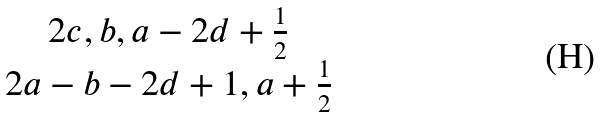<formula> <loc_0><loc_0><loc_500><loc_500>\begin{matrix} { 2 c , b , a - 2 d + \frac { 1 } { 2 } } \\ { 2 a - b - 2 d + 1 , a + \frac { 1 } { 2 } } \end{matrix}</formula> 